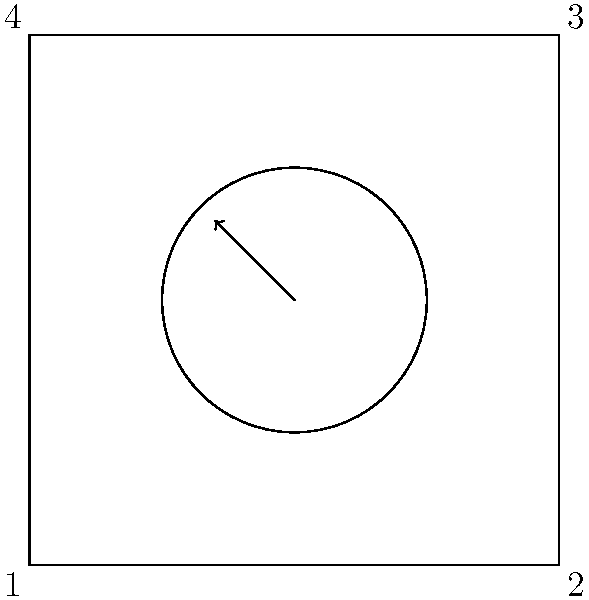In a pet adoption app interface, circular pet profile images are displayed in square containers. If a profile image is rotated 90° clockwise, which numbered position will the arrow in the image point towards? To solve this problem, we need to follow these steps:

1. Understand the initial position:
   - The circular profile image is inside a square container.
   - The arrow is currently pointing towards the top-right corner (between positions 3 and 4).

2. Visualize the rotation:
   - A 90° clockwise rotation means the image will turn a quarter turn to the right.

3. Determine the new arrow direction:
   - After a 90° clockwise rotation, the arrow that was pointing towards the top-right will now point towards the bottom-right corner.

4. Identify the corresponding numbered position:
   - The bottom-right corner of the square container is labeled as position 2.

Therefore, after a 90° clockwise rotation, the arrow in the pet profile image will point towards position 2.
Answer: 2 